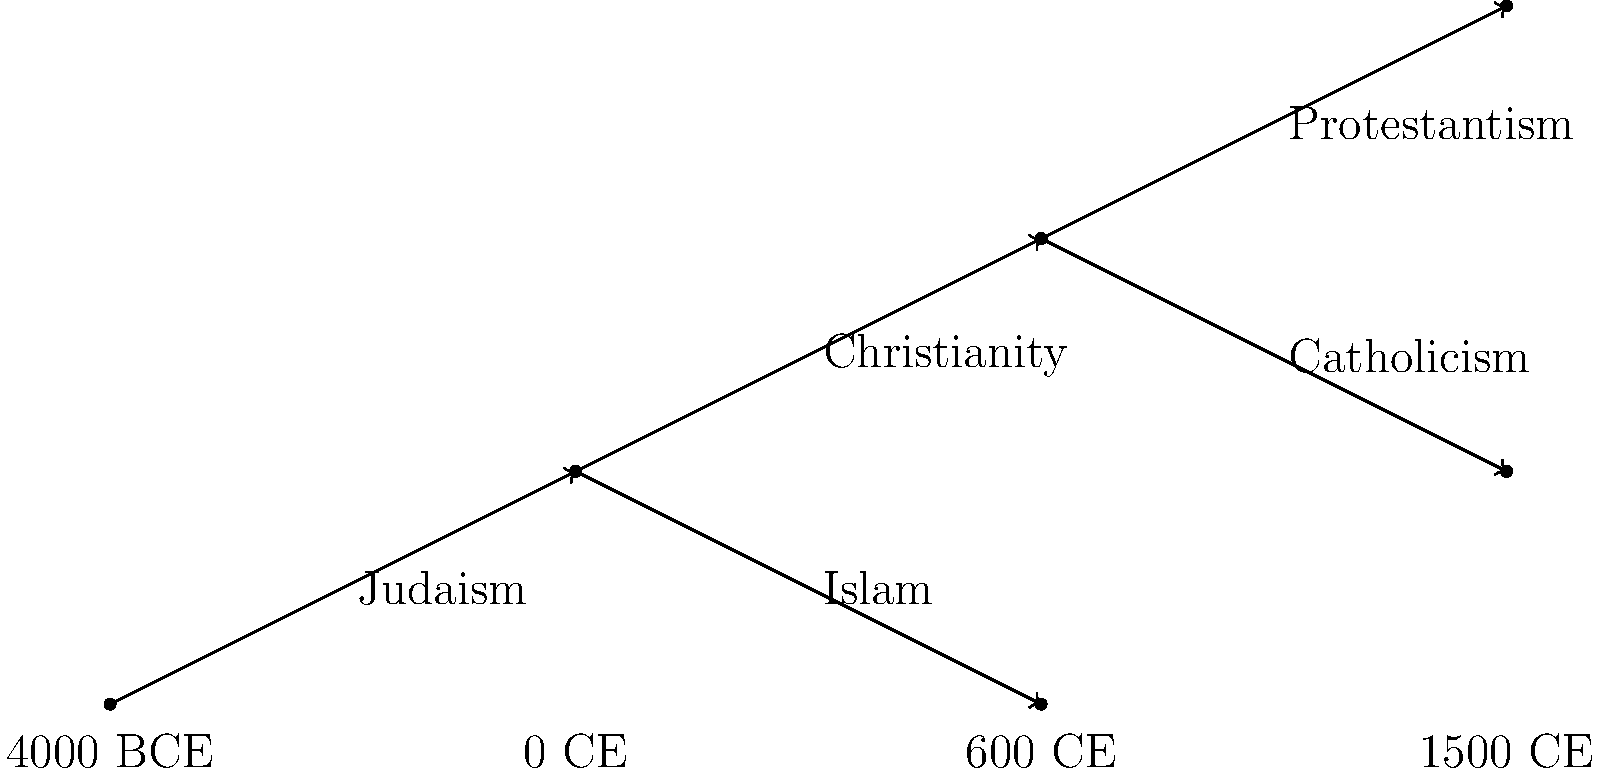Based on the historical timeline of major religious events represented as a branching tree, which significant religious movement emerged around 1500 CE as a branch from Christianity? To answer this question, we need to analyze the branching tree diagram of religious history:

1. The tree starts with Judaism at the origin, representing the earliest major monotheistic religion.

2. Around 0 CE, we see Christianity branching off from Judaism.

3. Around 600 CE, Islam emerges as another branch from Judaism.

4. The Christianity branch then splits into two major subdivisions:
   a. One branch leads to Catholicism
   b. The other branch leads to Protestantism

5. The timeline at the bottom of the diagram indicates that the final branching occurs around 1500 CE.

6. This branching from Christianity around 1500 CE corresponds to the emergence of Protestantism, which began with Martin Luther's Reformation in 1517.

Therefore, the significant religious movement that emerged around 1500 CE as a branch from Christianity, according to this timeline, is Protestantism.
Answer: Protestantism 